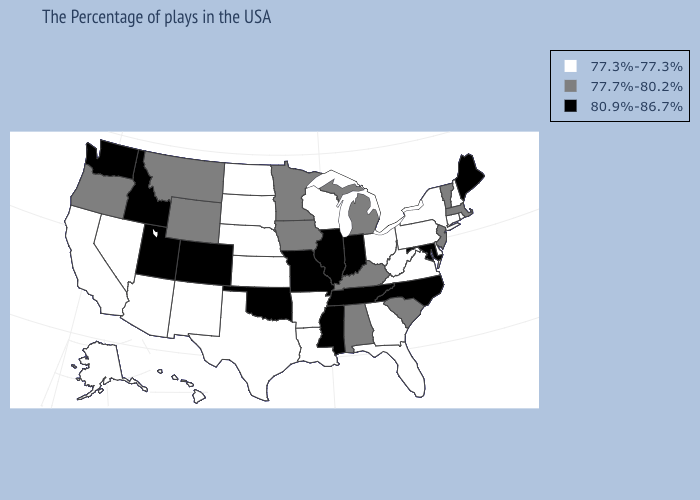What is the value of South Carolina?
Answer briefly. 77.7%-80.2%. Does Iowa have a lower value than Florida?
Concise answer only. No. Among the states that border Georgia , which have the highest value?
Write a very short answer. North Carolina, Tennessee. Does Nevada have a higher value than Florida?
Quick response, please. No. Does West Virginia have the same value as Florida?
Concise answer only. Yes. What is the value of Mississippi?
Concise answer only. 80.9%-86.7%. What is the value of Alaska?
Answer briefly. 77.3%-77.3%. Does North Dakota have the lowest value in the MidWest?
Quick response, please. Yes. What is the lowest value in the MidWest?
Be succinct. 77.3%-77.3%. What is the value of Pennsylvania?
Short answer required. 77.3%-77.3%. Among the states that border Maine , which have the lowest value?
Quick response, please. New Hampshire. Does Nebraska have the lowest value in the MidWest?
Keep it brief. Yes. Does Vermont have a lower value than Texas?
Be succinct. No. What is the lowest value in states that border North Carolina?
Concise answer only. 77.3%-77.3%. Among the states that border Mississippi , does Tennessee have the highest value?
Answer briefly. Yes. 